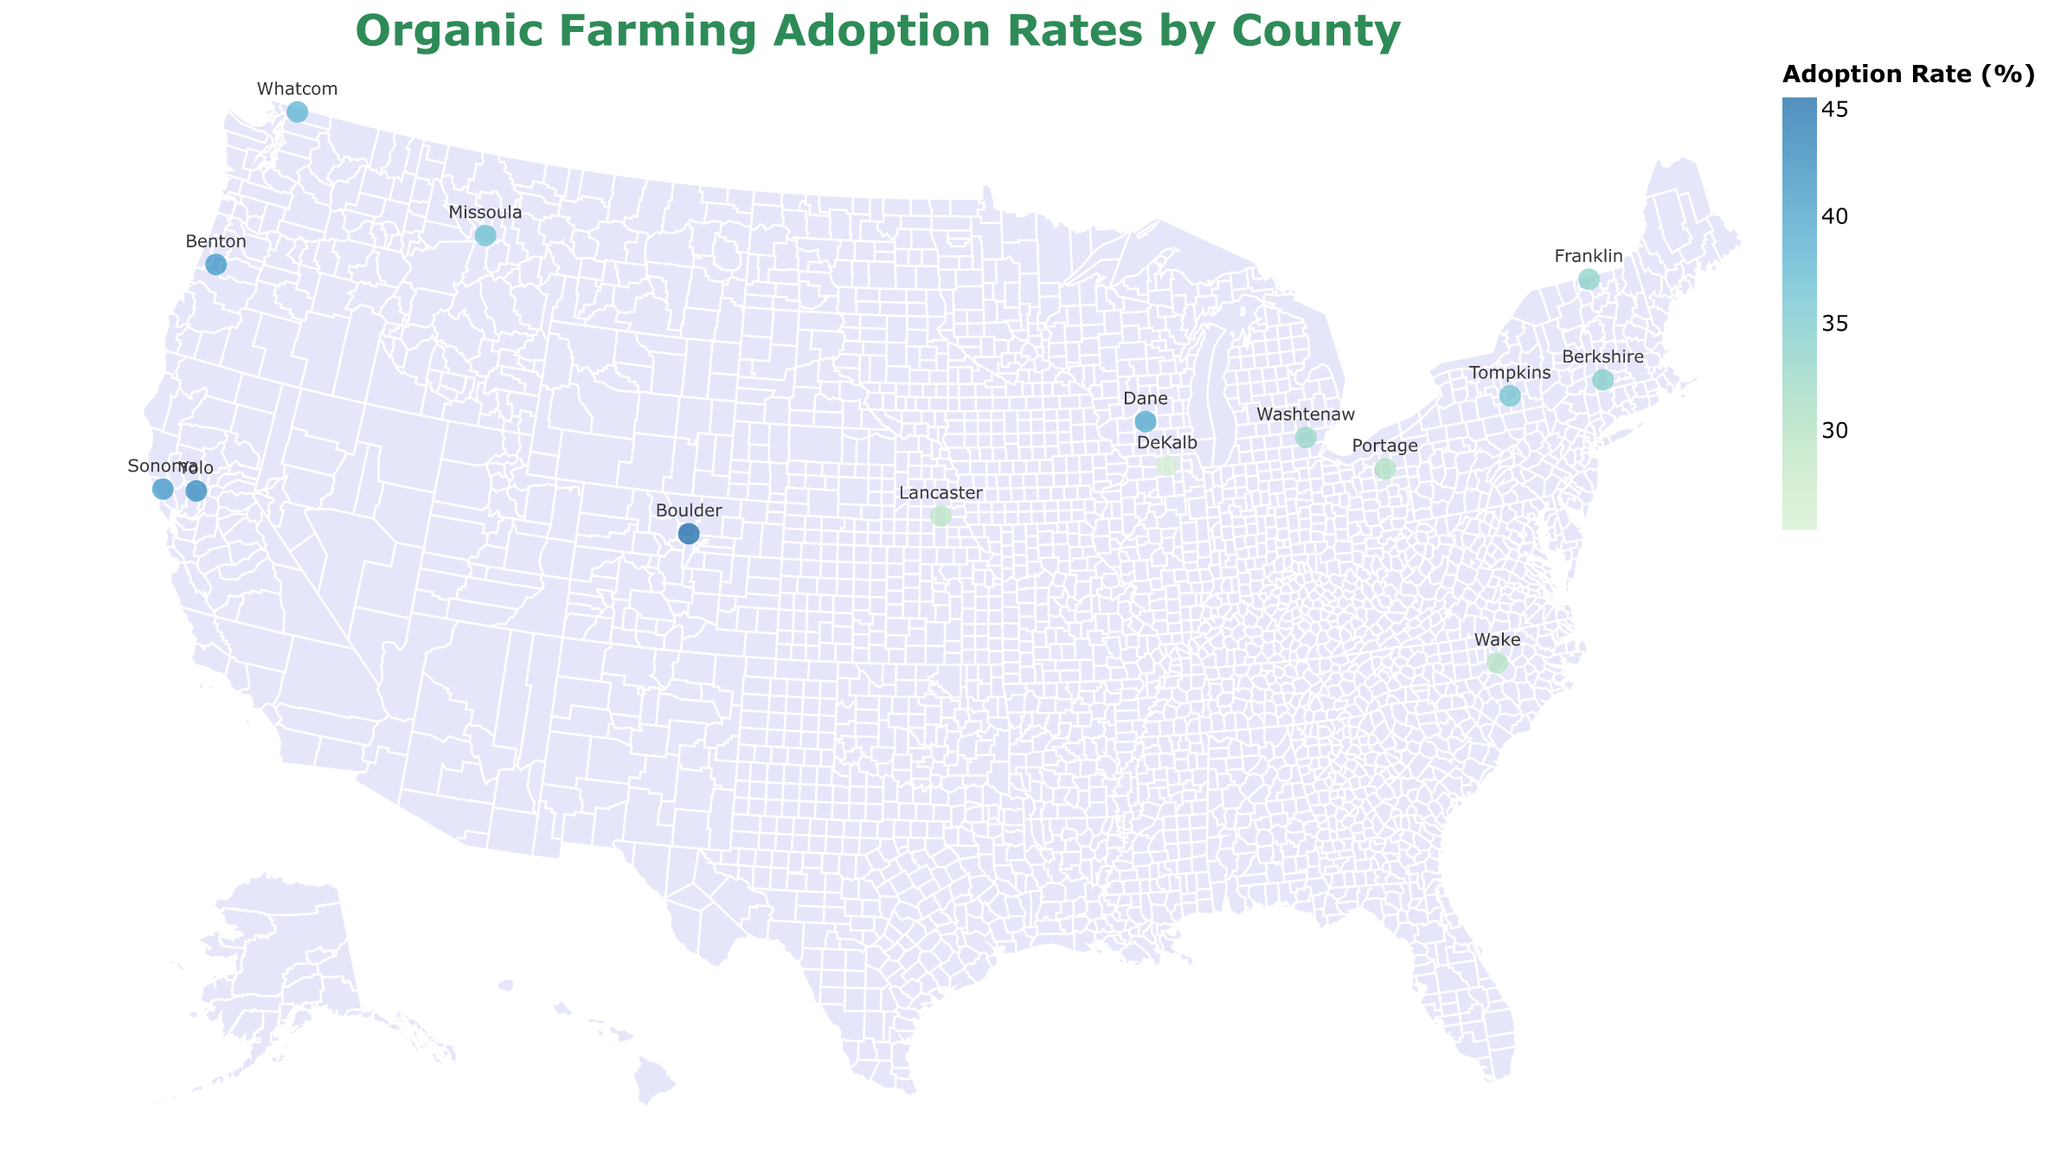Which county has the highest organic adoption rate? The highest organic adoption rate value is indicated by the darkest circle color. From the data points, Boulder County, Colorado, shows a rate of 45.6%, which is the highest.
Answer: Boulder County, Colorado What is the title of the figure? The title of the figure is displayed prominently at the top and is related to the topic of organic farming. It states "Organic Farming Adoption Rates by County."
Answer: Organic Farming Adoption Rates by County Compare the adoption rates of border counties in California. Which has a higher rate? Both Yolo County and Sonoma County are in California. By comparing their rates, Yolo County has an adoption rate of 42.3%, while Sonoma County has a rate of 40.8%. Hence, Yolo County has a higher rate.
Answer: Yolo County What color represents the counties with mid-range adoption rates? Mid-range adoption rates are visually represented in the color scale between the extreme light and dark color ends. This would be a color blending between the light green and dark blue, typically a shade of blue-green.
Answer: Blue-green Which state has multiple counties listed and how do their rates compare? California has two counties listed: Yolo and Sonoma. Their rates are 42.3% and 40.8%, respectively. By comparing, Yolo has a slightly higher rate than Sonoma.
Answer: California, Yolo > Sonoma What is the range of adoption rates for the plotted counties? The range is identified by the minimum and maximum adoption rates across the figure. The lowest rate is DeKalb County, Illinois at 25.4%, and the highest is Boulder County, Colorado at 45.6%. So, the range is 45.6% - 25.4%.
Answer: 20.2% Find the county in New York and provide its adoption rate. The county in New York listed in the figure is Tompkins County, and its organic adoption rate is 35.9%.
Answer: 35.9% Which county near the Great Lakes has an organic adoption rate above 30%? Counties near the Great Lakes in the dataset include Washtenaw, Michigan, and Portage, Ohio. Both have rates above 30%, with Washtenaw at 32.7% and Portage at 30.1%.
Answer: Washtenaw and Portage What is the average adoption rate among all listed counties? Calculating the average involves summing all the rates and dividing by the number of counties. Sum: 42.3 + 28.7 + 35.9 + 39.1 + 45.6 + 37.8 + 41.2 + 33.5 + 25.4 + 30.1 + 40.8 + 36.3 + 32.7 + 29.5 + 34.2 = 533.1. Number of counties: 15. Average: 533.1 / 15 ≈ 35.54%.
Answer: 35.54% 